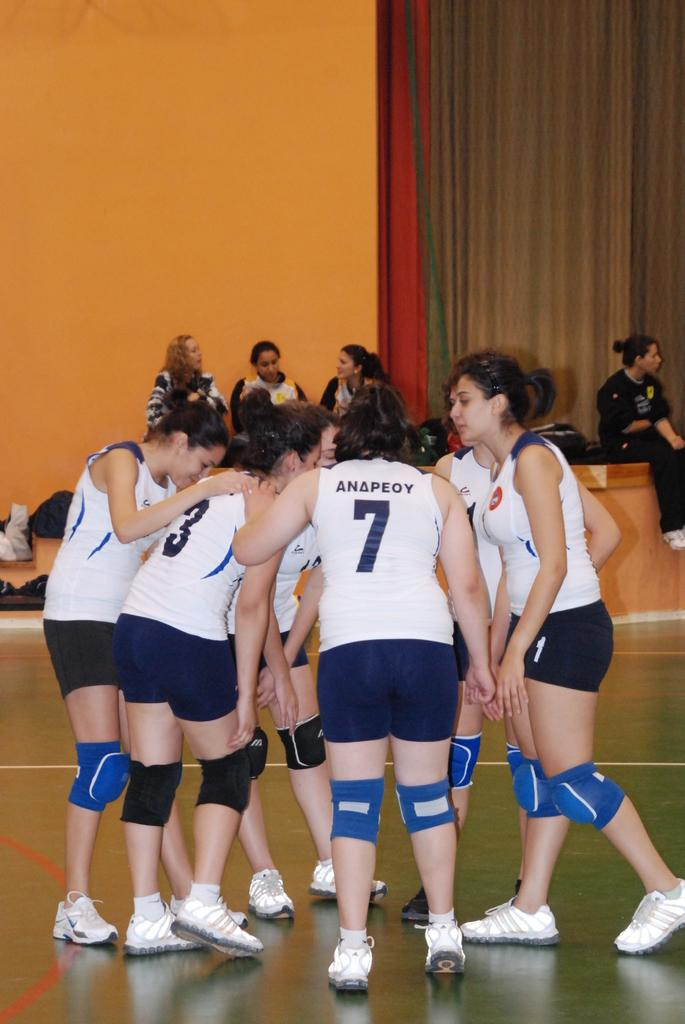<image>
Write a terse but informative summary of the picture. A group of women huddling during a sports game and one player has the last name Anapeoy. 